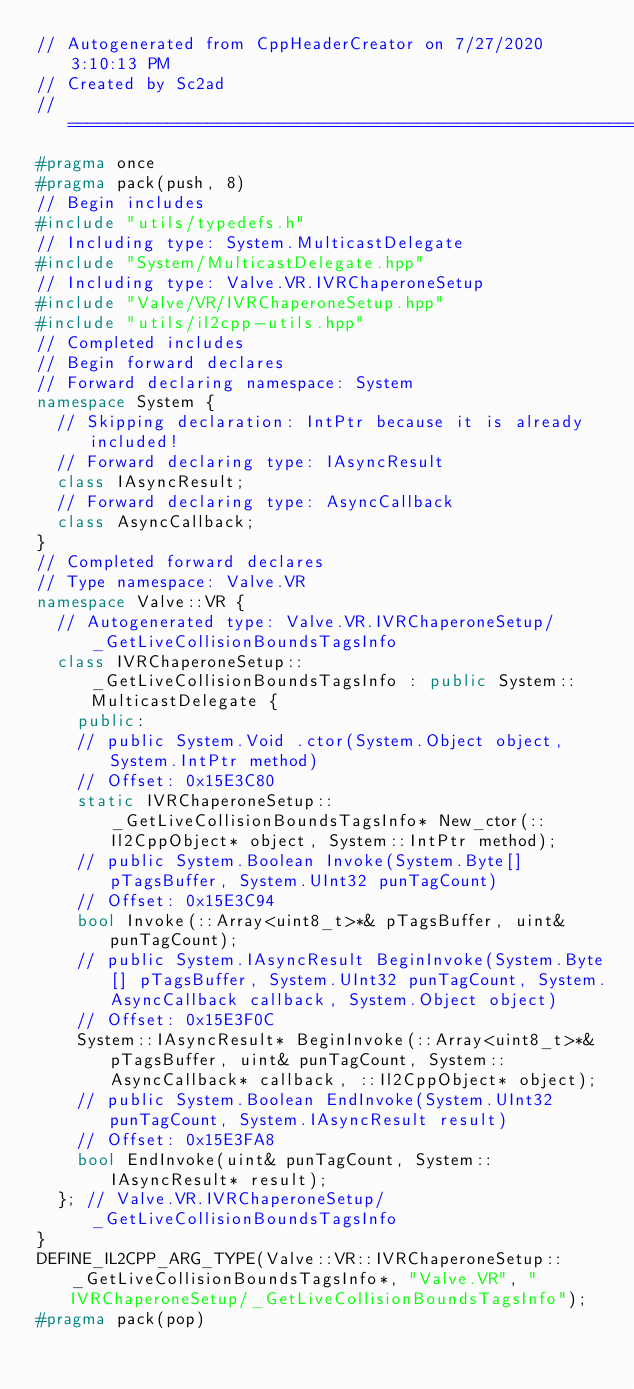<code> <loc_0><loc_0><loc_500><loc_500><_C++_>// Autogenerated from CppHeaderCreator on 7/27/2020 3:10:13 PM
// Created by Sc2ad
// =========================================================================
#pragma once
#pragma pack(push, 8)
// Begin includes
#include "utils/typedefs.h"
// Including type: System.MulticastDelegate
#include "System/MulticastDelegate.hpp"
// Including type: Valve.VR.IVRChaperoneSetup
#include "Valve/VR/IVRChaperoneSetup.hpp"
#include "utils/il2cpp-utils.hpp"
// Completed includes
// Begin forward declares
// Forward declaring namespace: System
namespace System {
  // Skipping declaration: IntPtr because it is already included!
  // Forward declaring type: IAsyncResult
  class IAsyncResult;
  // Forward declaring type: AsyncCallback
  class AsyncCallback;
}
// Completed forward declares
// Type namespace: Valve.VR
namespace Valve::VR {
  // Autogenerated type: Valve.VR.IVRChaperoneSetup/_GetLiveCollisionBoundsTagsInfo
  class IVRChaperoneSetup::_GetLiveCollisionBoundsTagsInfo : public System::MulticastDelegate {
    public:
    // public System.Void .ctor(System.Object object, System.IntPtr method)
    // Offset: 0x15E3C80
    static IVRChaperoneSetup::_GetLiveCollisionBoundsTagsInfo* New_ctor(::Il2CppObject* object, System::IntPtr method);
    // public System.Boolean Invoke(System.Byte[] pTagsBuffer, System.UInt32 punTagCount)
    // Offset: 0x15E3C94
    bool Invoke(::Array<uint8_t>*& pTagsBuffer, uint& punTagCount);
    // public System.IAsyncResult BeginInvoke(System.Byte[] pTagsBuffer, System.UInt32 punTagCount, System.AsyncCallback callback, System.Object object)
    // Offset: 0x15E3F0C
    System::IAsyncResult* BeginInvoke(::Array<uint8_t>*& pTagsBuffer, uint& punTagCount, System::AsyncCallback* callback, ::Il2CppObject* object);
    // public System.Boolean EndInvoke(System.UInt32 punTagCount, System.IAsyncResult result)
    // Offset: 0x15E3FA8
    bool EndInvoke(uint& punTagCount, System::IAsyncResult* result);
  }; // Valve.VR.IVRChaperoneSetup/_GetLiveCollisionBoundsTagsInfo
}
DEFINE_IL2CPP_ARG_TYPE(Valve::VR::IVRChaperoneSetup::_GetLiveCollisionBoundsTagsInfo*, "Valve.VR", "IVRChaperoneSetup/_GetLiveCollisionBoundsTagsInfo");
#pragma pack(pop)
</code> 